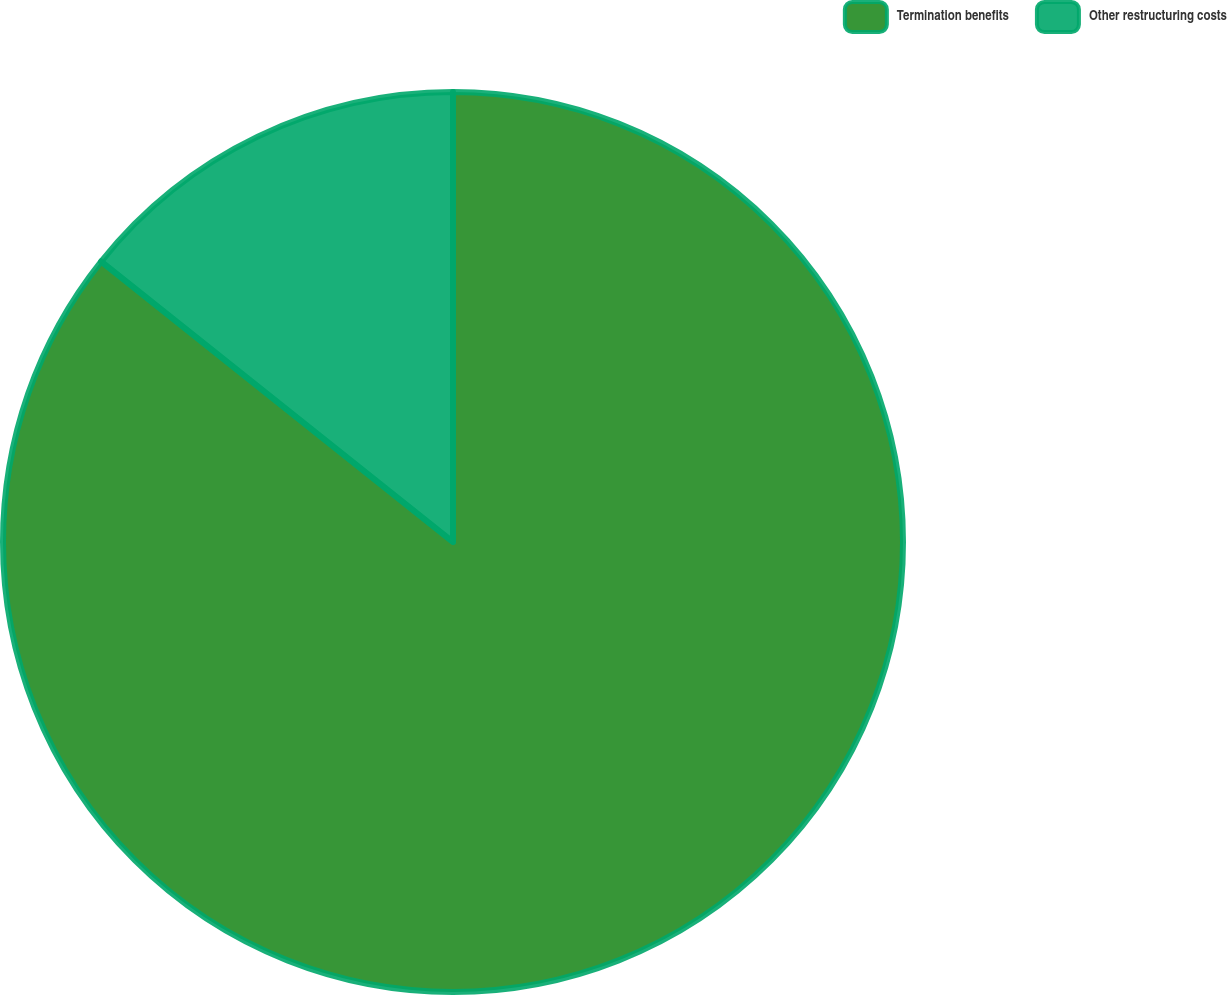Convert chart to OTSL. <chart><loc_0><loc_0><loc_500><loc_500><pie_chart><fcel>Termination benefits<fcel>Other restructuring costs<nl><fcel>85.71%<fcel>14.29%<nl></chart> 